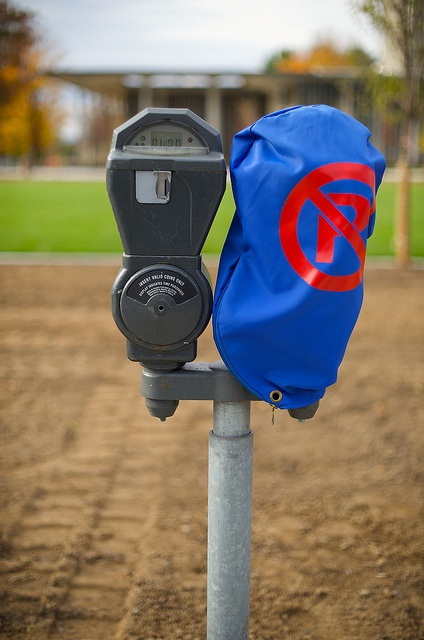Describe the objects in this image and their specific colors. I can see parking meter in dimgray, darkblue, blue, and red tones and parking meter in dimgray, black, gray, and darkgray tones in this image. 